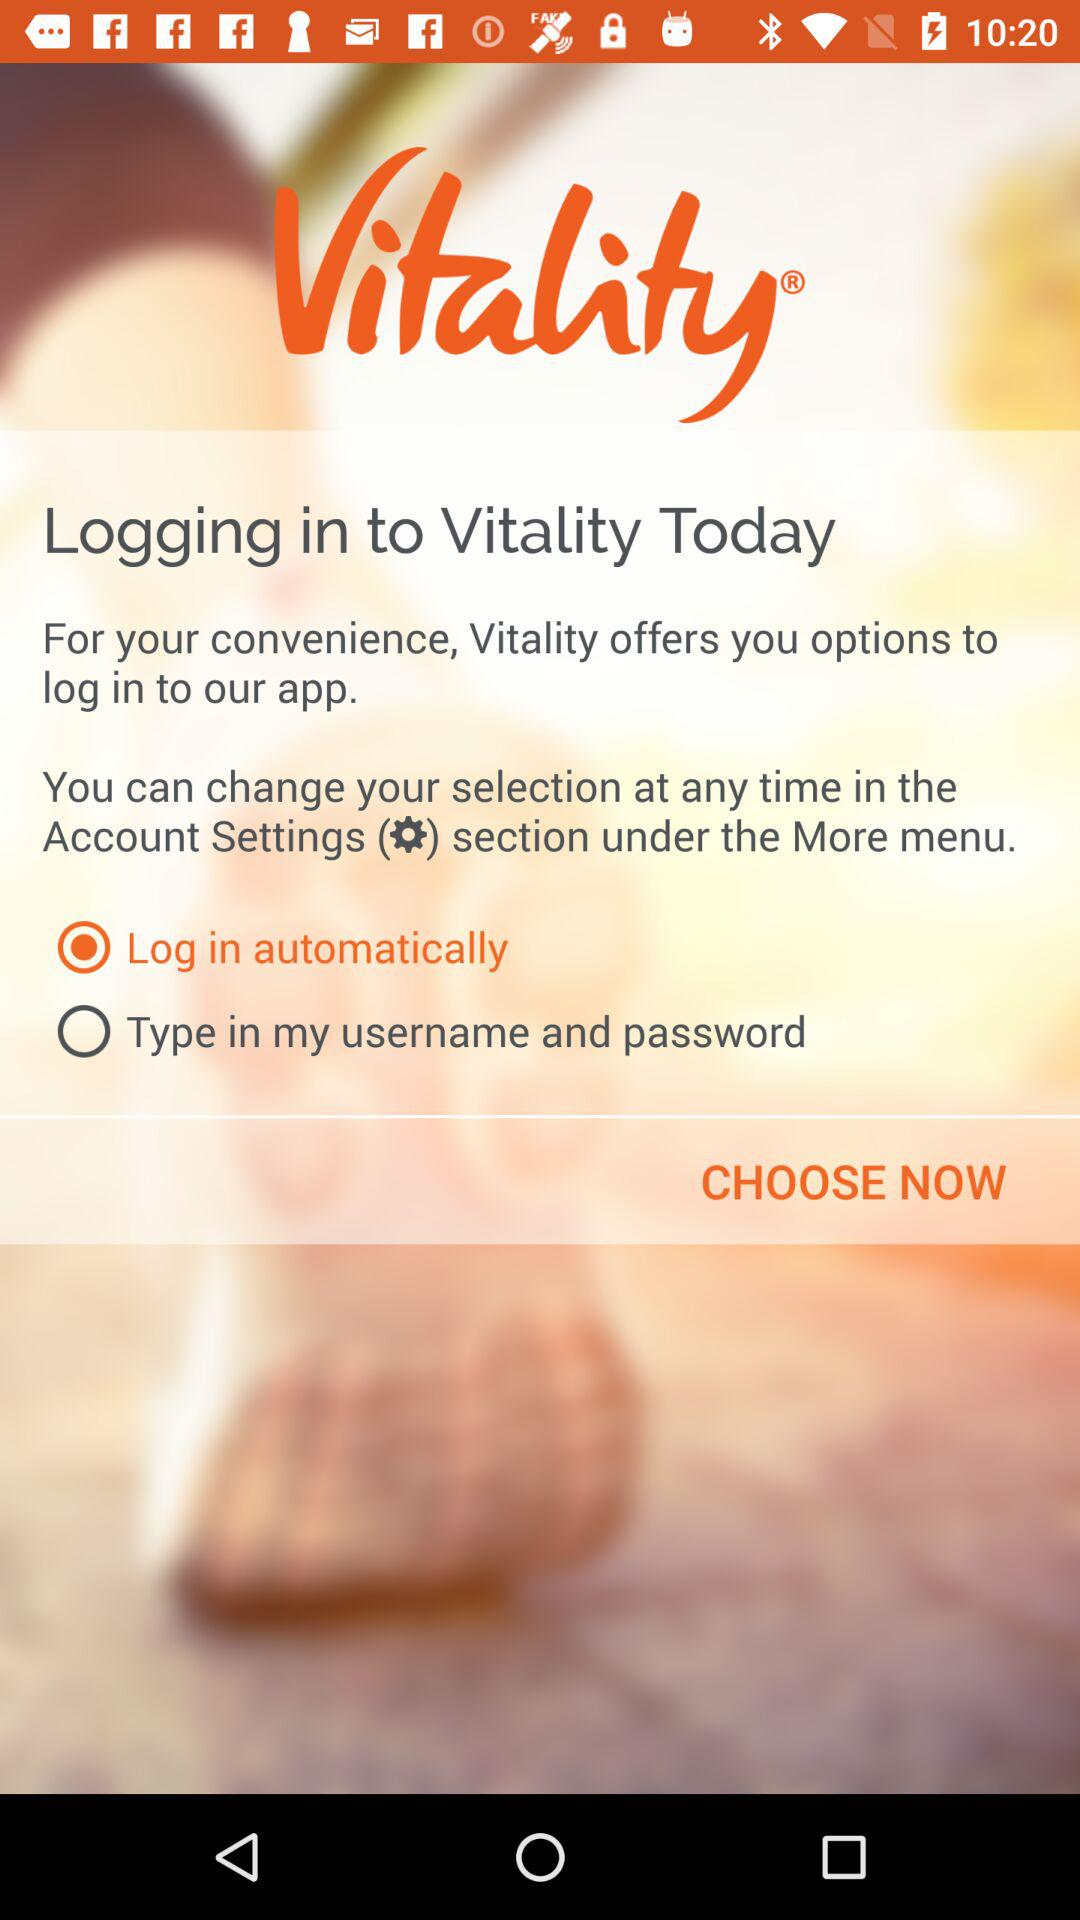Which option is selected to log in to the application? The option that is selected to log in to the application is "Log in automatically". 